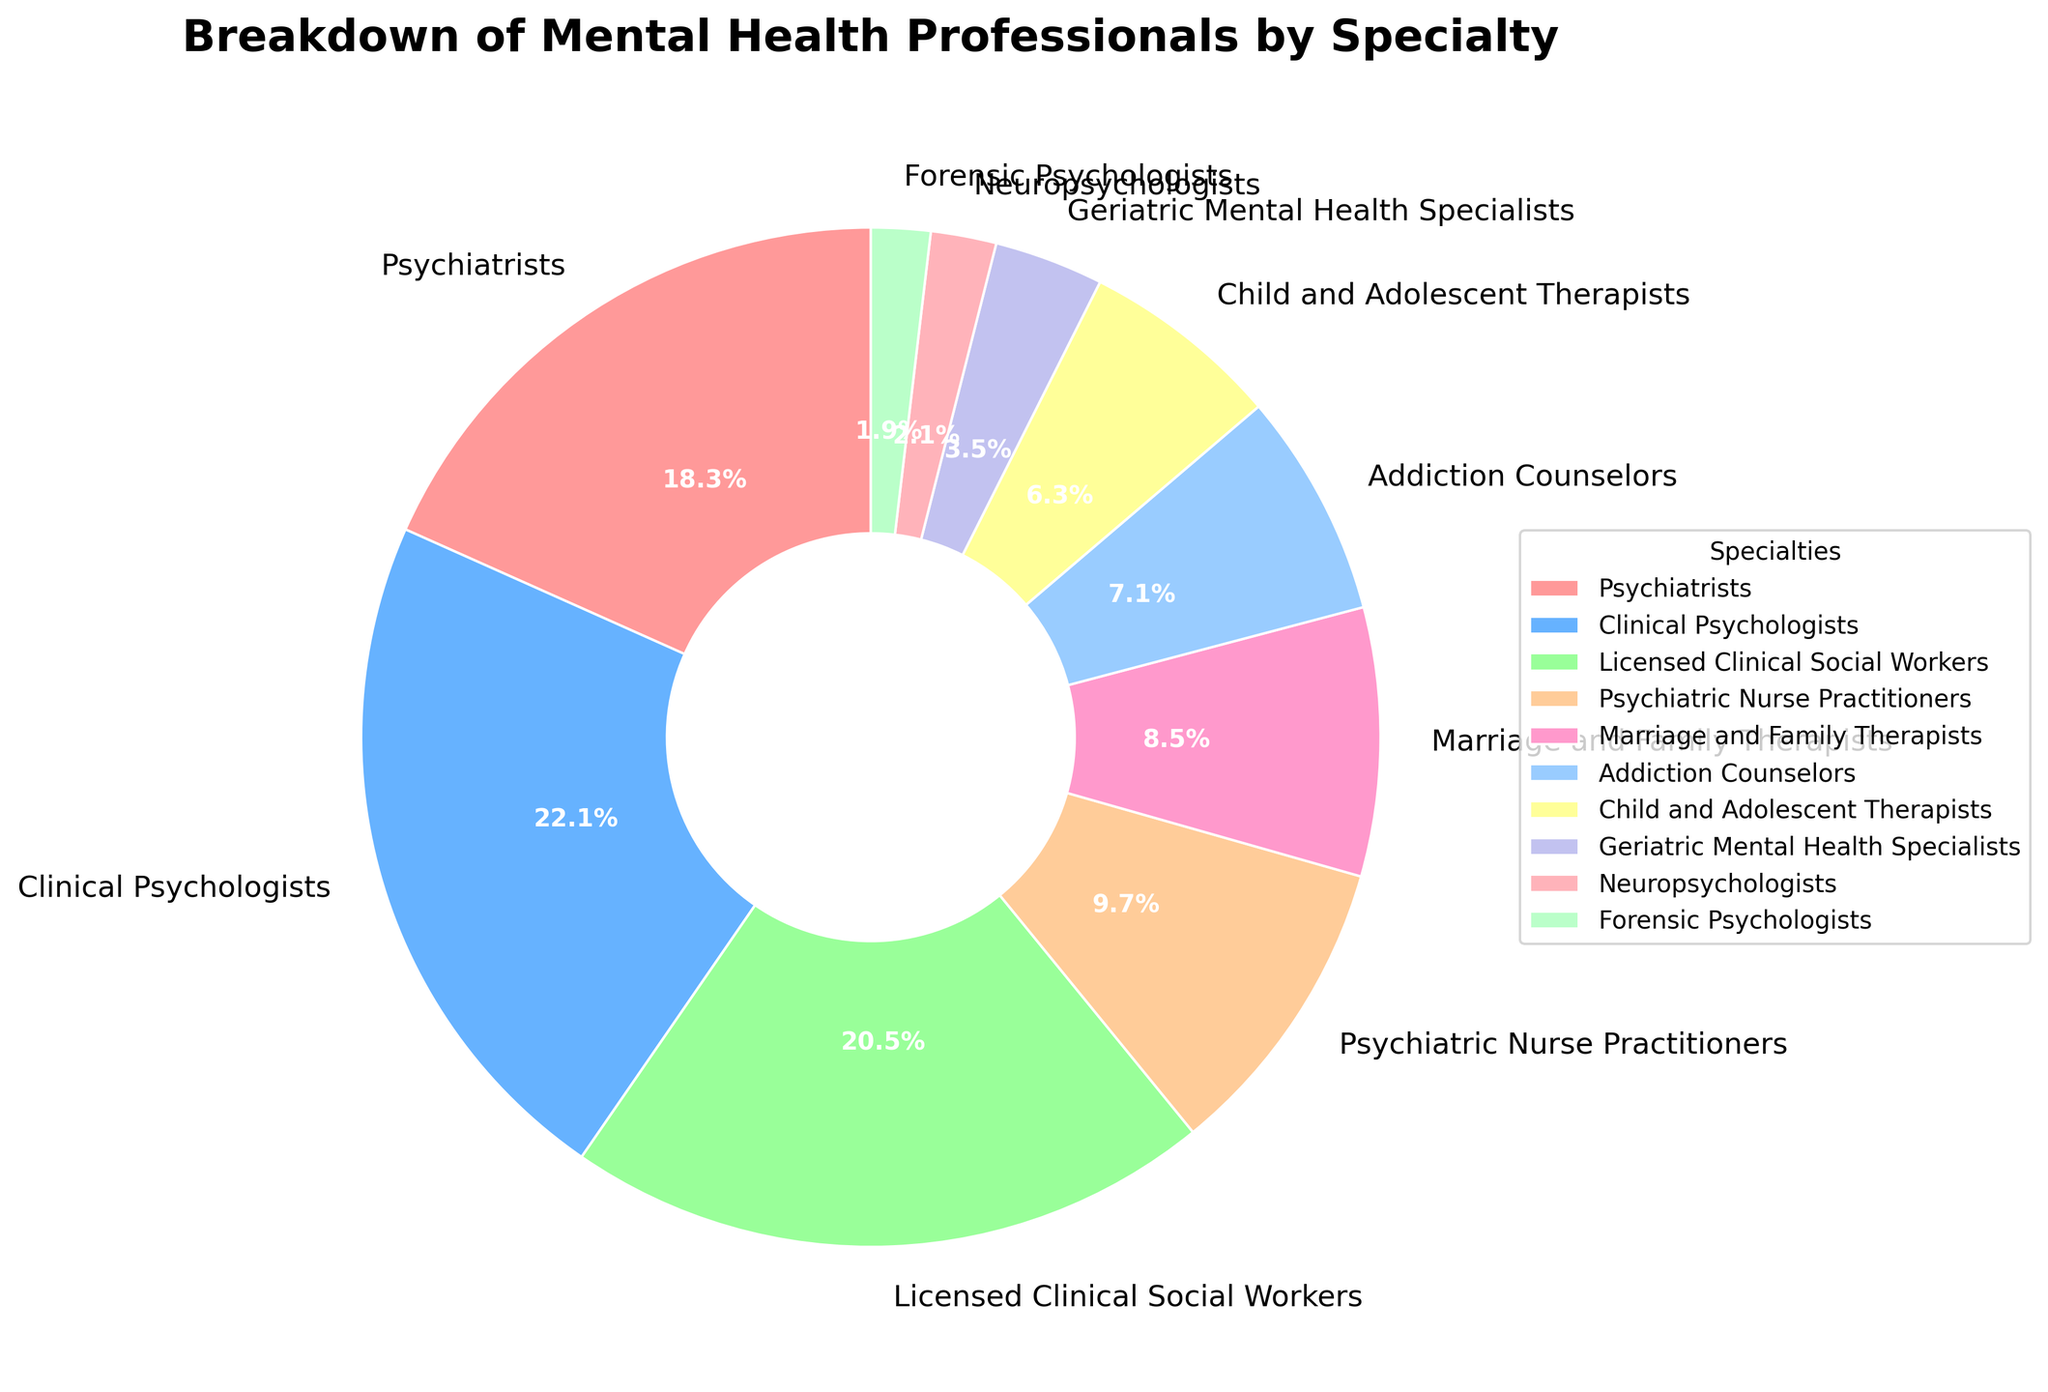What percentage of mental health professionals are Clinical Psychologists? Look at the pie chart and find the section labeled "Clinical Psychologists". The percentage is listed in this section.
Answer: 22.3% What is the total percentage of Psychiatrists, Clinical Psychologists, and Licensed Clinical Social Workers combined? Sum the percentages for Psychiatrists (18.5%), Clinical Psychologists (22.3%), and Licensed Clinical Social Workers (20.7%). 18.5 + 22.3 + 20.7 = 61.5%
Answer: 61.5% Which specialty has the smallest representation among mental health professionals? Identify the smallest slice in the pie chart. The label here indicates that "Forensic Psychologists" have the smallest percentage.
Answer: Forensic Psychologists How many specialties have a percentage greater than 10%? Scan the pie chart for all slices that indicate a percentage greater than 10%. There are three such specialties: Psychiatrists (18.5%), Clinical Psychologists (22.3%), and Licensed Clinical Social Workers (20.7%).
Answer: 3 Compare the representation of Child and Adolescent Therapists and Marriage and Family Therapists. Which is larger and by how much? Locate the percentages for both specialties: Child and Adolescent Therapists (6.4%) and Marriage and Family Therapists (8.6%). Subtract the smaller percentage from the larger: 8.6 - 6.4 = 2.2%.
Answer: Marriage and Family Therapists by 2.2% What is the combined percentage of specialties with less than 5% representation? Add the percentages for specialties with less than 5%: Geriatric Mental Health Specialists (3.5%), Neuropsychologists (2.1%), and Forensic Psychologists (1.9%). 3.5 + 2.1 + 1.9 = 7.5%
Answer: 7.5% Compare the representations of Addiction Counselors and Psychiatric Nurse Practitioners. Which one is larger? Identify the percentages for both specialties: Addiction Counselors (7.2%) and Psychiatric Nurse Practitioners (9.8%). The larger percentage indicates that Psychiatric Nurse Practitioners are more represented.
Answer: Psychiatric Nurse Practitioners What is the sum of the percentages for Addiction Counselors, Child and Adolescent Therapists, and Geriatric Mental Health Specialists? Add the percentages for these specialties: Addiction Counselors (7.2%), Child and Adolescent Therapists (6.4%), and Geriatric Mental Health Specialists (3.5%). 7.2 + 6.4 + 3.5 = 17.1%
Answer: 17.1% Which specialty is represented by the green-colored slice in the pie chart? Locate the green-colored slice and refer to its label. The label indicates that "Clinical Psychologists" are represented by the green-colored slice.
Answer: Clinical Psychologists 